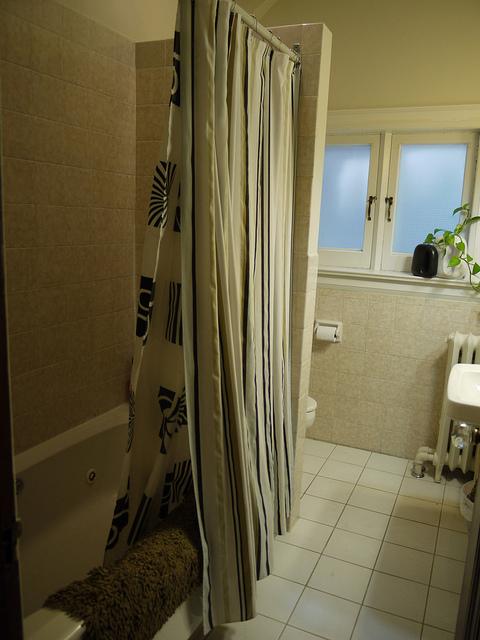Would you cook in this room?
Short answer required. No. How many windows are in the picture?
Short answer required. 2. What is hanging on the tub?
Write a very short answer. Rug. Is the window open?
Keep it brief. No. What's the color of the towel?
Write a very short answer. Brown. What color are the floor tiles?
Write a very short answer. White. 